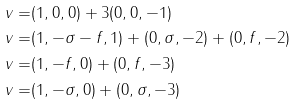Convert formula to latex. <formula><loc_0><loc_0><loc_500><loc_500>v = & ( 1 , 0 , 0 ) + 3 ( 0 , 0 , - 1 ) \\ v = & ( 1 , - \sigma - f , 1 ) + ( 0 , \sigma , - 2 ) + ( 0 , f , - 2 ) \\ v = & ( 1 , - f , 0 ) + ( 0 , f , - 3 ) \\ v = & ( 1 , - \sigma , 0 ) + ( 0 , \sigma , - 3 )</formula> 